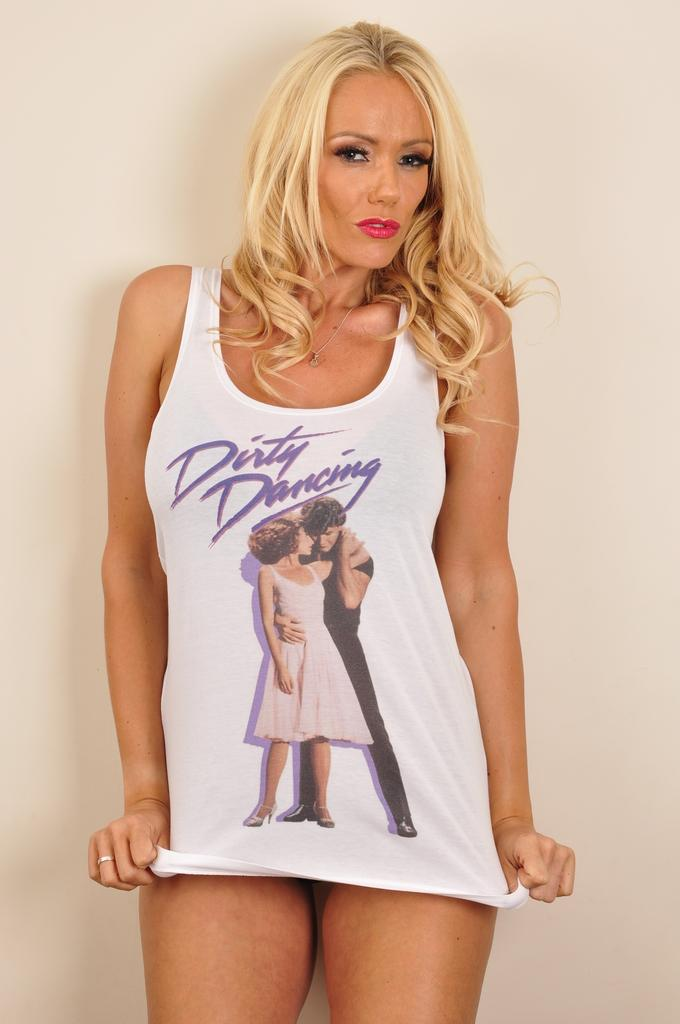Who is the main subject in the image? There is a woman in the image. What is the woman wearing? The woman is wearing a white T-shirt. What is the woman doing in the image? The woman is standing and posing for a photo. What is the color of the background in the image? The background of the image is white in color. What type of bread can be seen falling from the sky in the image? There is no bread or any falling objects present in the image. 